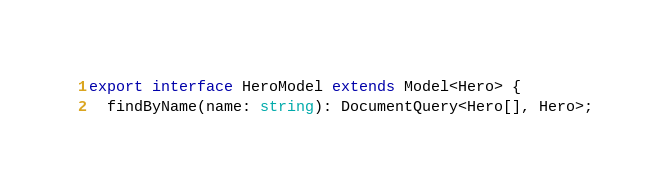<code> <loc_0><loc_0><loc_500><loc_500><_TypeScript_>export interface HeroModel extends Model<Hero> {
  findByName(name: string): DocumentQuery<Hero[], Hero>;</code> 